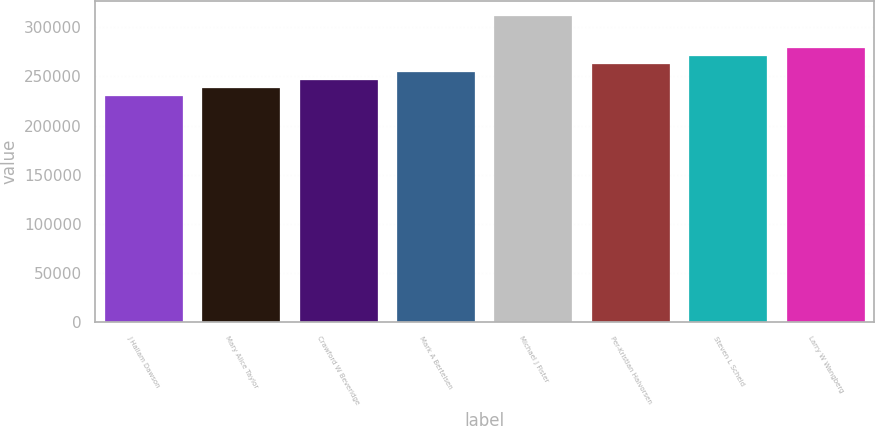<chart> <loc_0><loc_0><loc_500><loc_500><bar_chart><fcel>J Hallam Dawson<fcel>Mary Alice Taylor<fcel>Crawford W Beveridge<fcel>Mark A Bertelsen<fcel>Michael J Fister<fcel>Per-Kristian Halvorsen<fcel>Steven L Scheid<fcel>Larry W Wangberg<nl><fcel>230493<fcel>238596<fcel>246699<fcel>254802<fcel>311522<fcel>262905<fcel>271008<fcel>279110<nl></chart> 